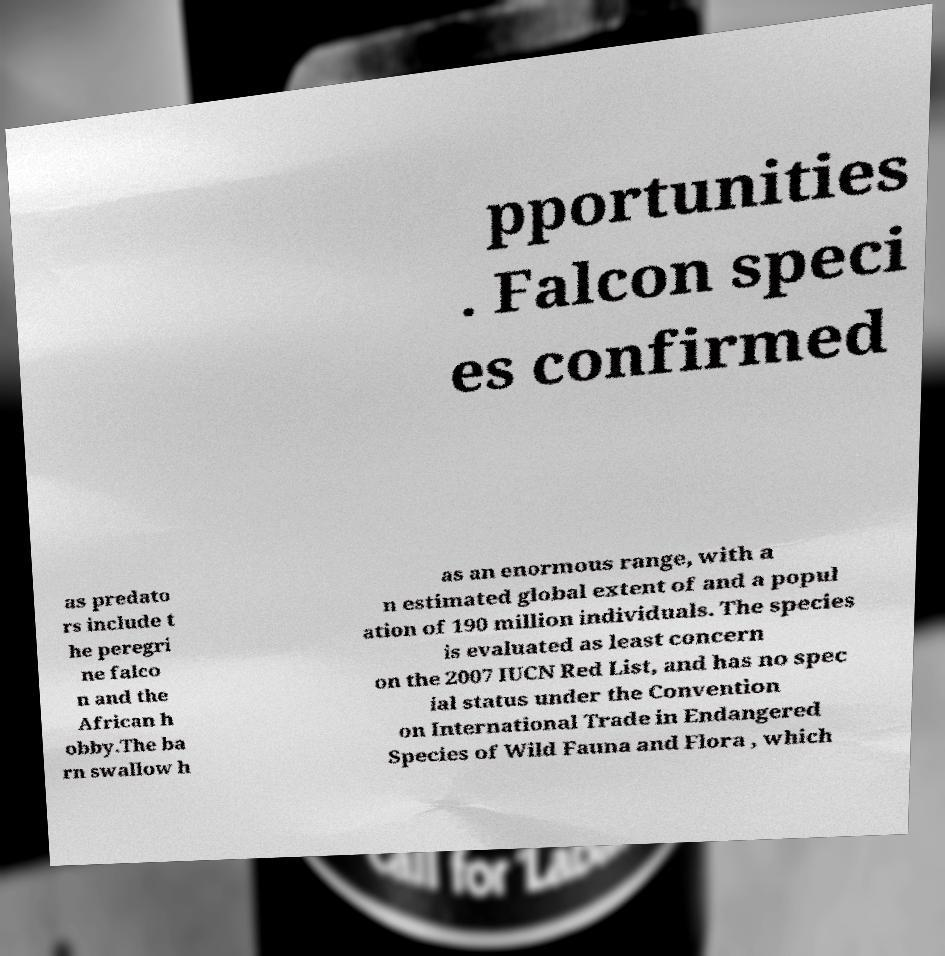Could you assist in decoding the text presented in this image and type it out clearly? pportunities . Falcon speci es confirmed as predato rs include t he peregri ne falco n and the African h obby.The ba rn swallow h as an enormous range, with a n estimated global extent of and a popul ation of 190 million individuals. The species is evaluated as least concern on the 2007 IUCN Red List, and has no spec ial status under the Convention on International Trade in Endangered Species of Wild Fauna and Flora , which 